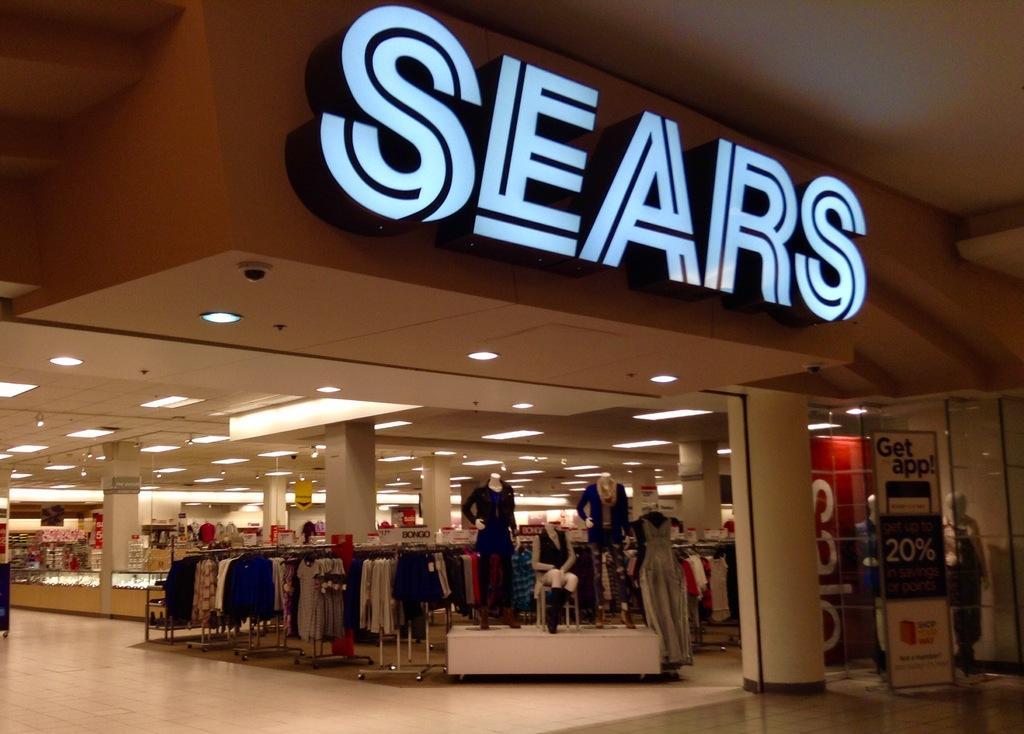Could you give a brief overview of what you see in this image? In this image I can see number of clothes, number of lights, few mannequin, few boards and on these boards I can see something is written. I can also see something is written over here. 